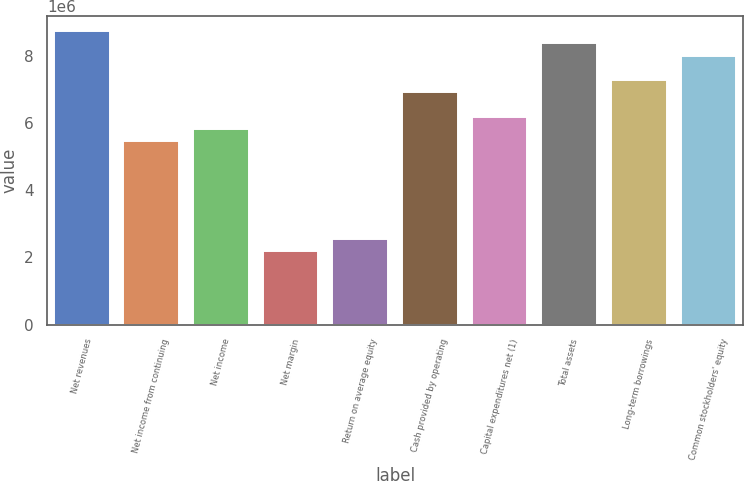Convert chart to OTSL. <chart><loc_0><loc_0><loc_500><loc_500><bar_chart><fcel>Net revenues<fcel>Net income from continuing<fcel>Net income<fcel>Net margin<fcel>Return on average equity<fcel>Cash provided by operating<fcel>Capital expenditures net (1)<fcel>Total assets<fcel>Long-term borrowings<fcel>Common stockholders' equity<nl><fcel>8.72998e+06<fcel>5.45623e+06<fcel>5.81998e+06<fcel>2.18249e+06<fcel>2.54624e+06<fcel>6.91123e+06<fcel>6.18373e+06<fcel>8.36623e+06<fcel>7.27498e+06<fcel>8.00248e+06<nl></chart> 